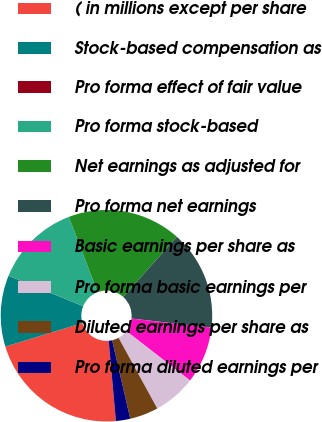Convert chart to OTSL. <chart><loc_0><loc_0><loc_500><loc_500><pie_chart><fcel>( in millions except per share<fcel>Stock-based compensation as<fcel>Pro forma effect of fair value<fcel>Pro forma stock-based<fcel>Net earnings as adjusted for<fcel>Pro forma net earnings<fcel>Basic earnings per share as<fcel>Pro forma basic earnings per<fcel>Diluted earnings per share as<fcel>Pro forma diluted earnings per<nl><fcel>21.71%<fcel>10.87%<fcel>0.02%<fcel>13.04%<fcel>17.37%<fcel>15.21%<fcel>8.7%<fcel>6.53%<fcel>4.36%<fcel>2.19%<nl></chart> 